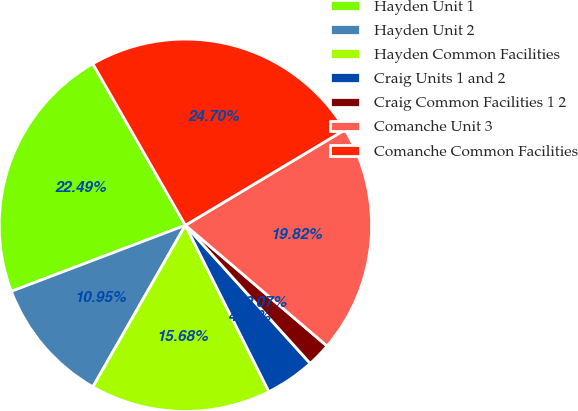Convert chart. <chart><loc_0><loc_0><loc_500><loc_500><pie_chart><fcel>Hayden Unit 1<fcel>Hayden Unit 2<fcel>Hayden Common Facilities<fcel>Craig Units 1 and 2<fcel>Craig Common Facilities 1 2<fcel>Comanche Unit 3<fcel>Comanche Common Facilities<nl><fcel>22.49%<fcel>10.95%<fcel>15.68%<fcel>4.29%<fcel>2.07%<fcel>19.82%<fcel>24.7%<nl></chart> 